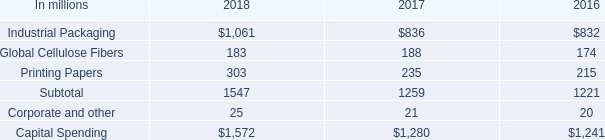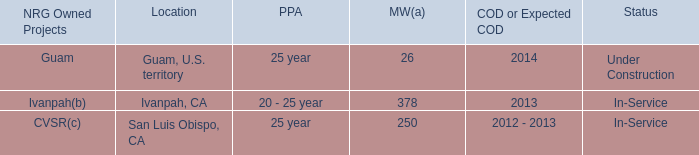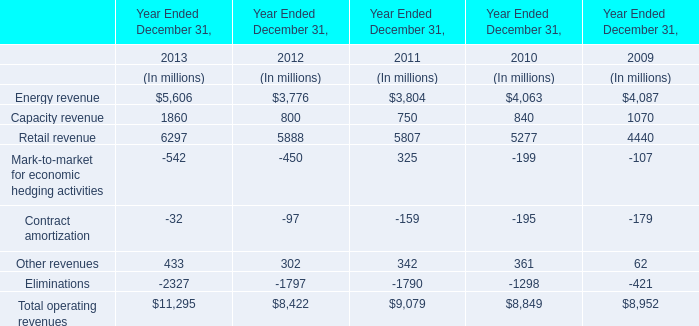What is the growing rate of Retail revenue in the year with the least Total operating revenues? 
Computations: ((5888 - 5807) / 5807)
Answer: 0.01395. 